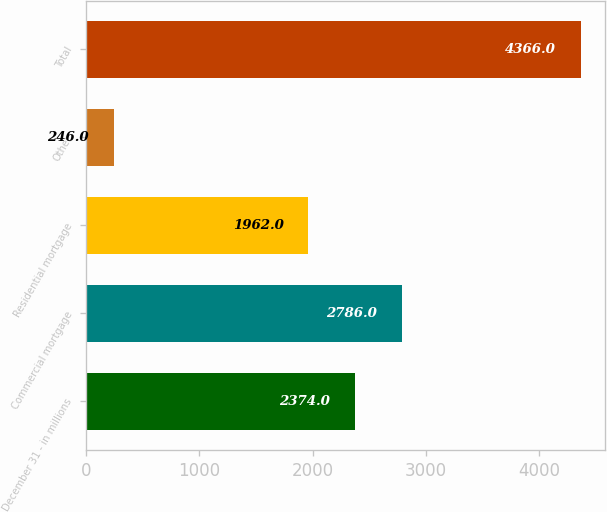<chart> <loc_0><loc_0><loc_500><loc_500><bar_chart><fcel>December 31 - in millions<fcel>Commercial mortgage<fcel>Residential mortgage<fcel>Other<fcel>Total<nl><fcel>2374<fcel>2786<fcel>1962<fcel>246<fcel>4366<nl></chart> 